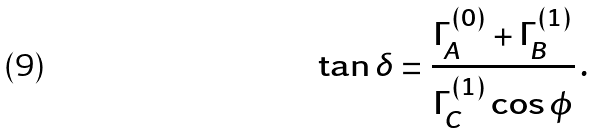<formula> <loc_0><loc_0><loc_500><loc_500>\tan \delta = \frac { \Gamma _ { A } ^ { ( 0 ) } + \Gamma _ { B } ^ { ( 1 ) } } { \Gamma _ { C } ^ { ( 1 ) } \cos \phi } \, .</formula> 